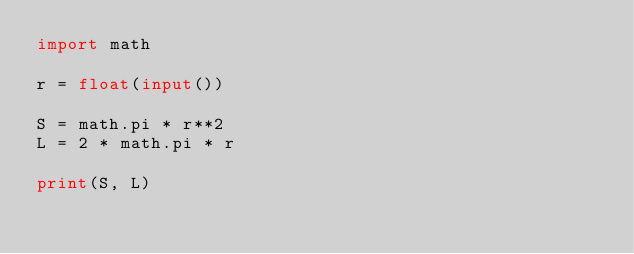Convert code to text. <code><loc_0><loc_0><loc_500><loc_500><_Python_>import math

r = float(input())

S = math.pi * r**2
L = 2 * math.pi * r

print(S, L)</code> 